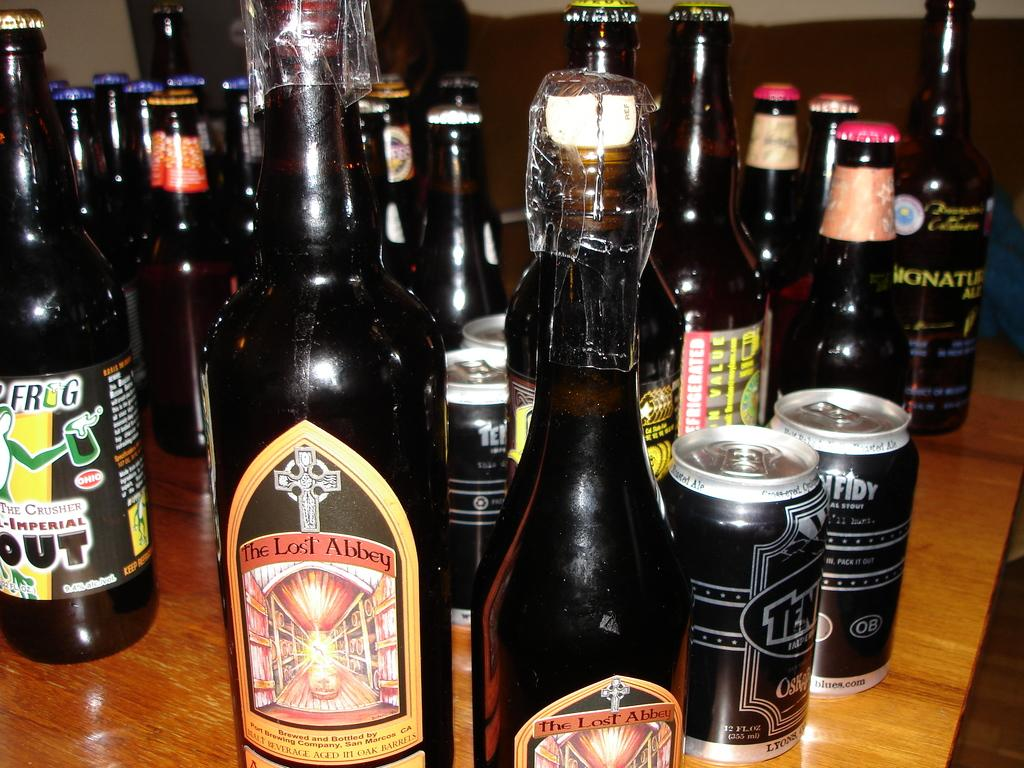Provide a one-sentence caption for the provided image. A bottle has a label with a cross and text of The Lost Abbey. 